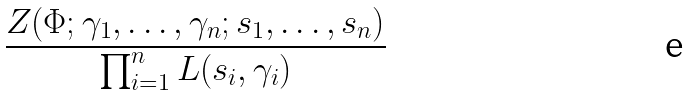<formula> <loc_0><loc_0><loc_500><loc_500>\frac { Z ( \Phi ; \gamma _ { 1 } , \dots , \gamma _ { n } ; s _ { 1 } , \dots , s _ { n } ) } { \prod _ { i = 1 } ^ { n } L ( s _ { i } , \gamma _ { i } ) }</formula> 